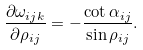<formula> <loc_0><loc_0><loc_500><loc_500>\frac { \partial \omega _ { i j k } } { \partial \rho _ { i j } } = - \frac { \cot \alpha _ { i j } } { \sin \rho _ { i j } } .</formula> 